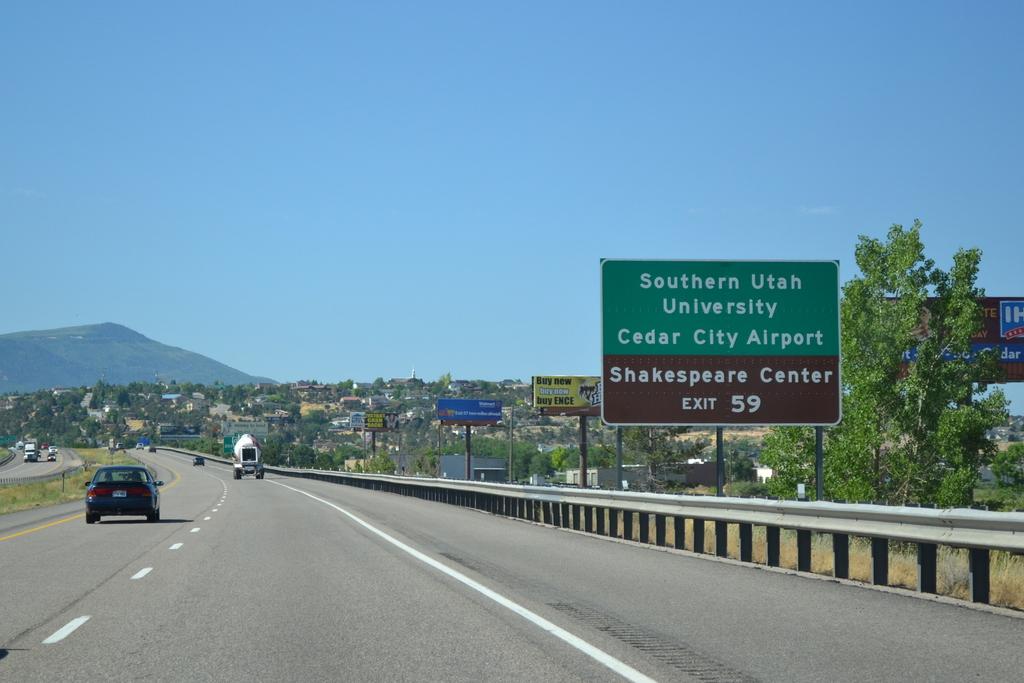What is at exit 59?
Your response must be concise. Shakespeare center. 